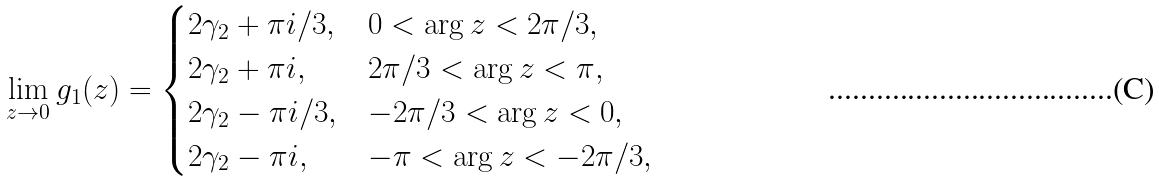<formula> <loc_0><loc_0><loc_500><loc_500>\lim _ { z \to 0 } g _ { 1 } ( z ) = \begin{cases} 2 \gamma _ { 2 } + \pi i / 3 , & 0 < \arg z < 2 \pi / 3 , \\ 2 \gamma _ { 2 } + \pi i , & 2 \pi / 3 < \arg z < \pi , \\ 2 \gamma _ { 2 } - \pi i / 3 , & - 2 \pi / 3 < \arg z < 0 , \\ 2 \gamma _ { 2 } - \pi i , & - \pi < \arg z < - 2 \pi / 3 , \end{cases}</formula> 